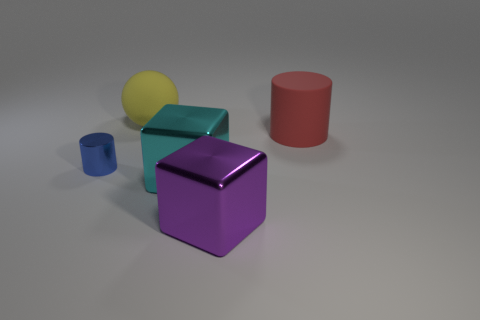Add 5 cyan shiny cubes. How many cyan shiny cubes are left? 6 Add 1 large yellow balls. How many large yellow balls exist? 2 Add 4 tiny matte cubes. How many objects exist? 9 Subtract 0 green cylinders. How many objects are left? 5 Subtract all spheres. How many objects are left? 4 Subtract all red cylinders. Subtract all red cubes. How many cylinders are left? 1 Subtract all gray cubes. How many red cylinders are left? 1 Subtract all purple objects. Subtract all small shiny things. How many objects are left? 3 